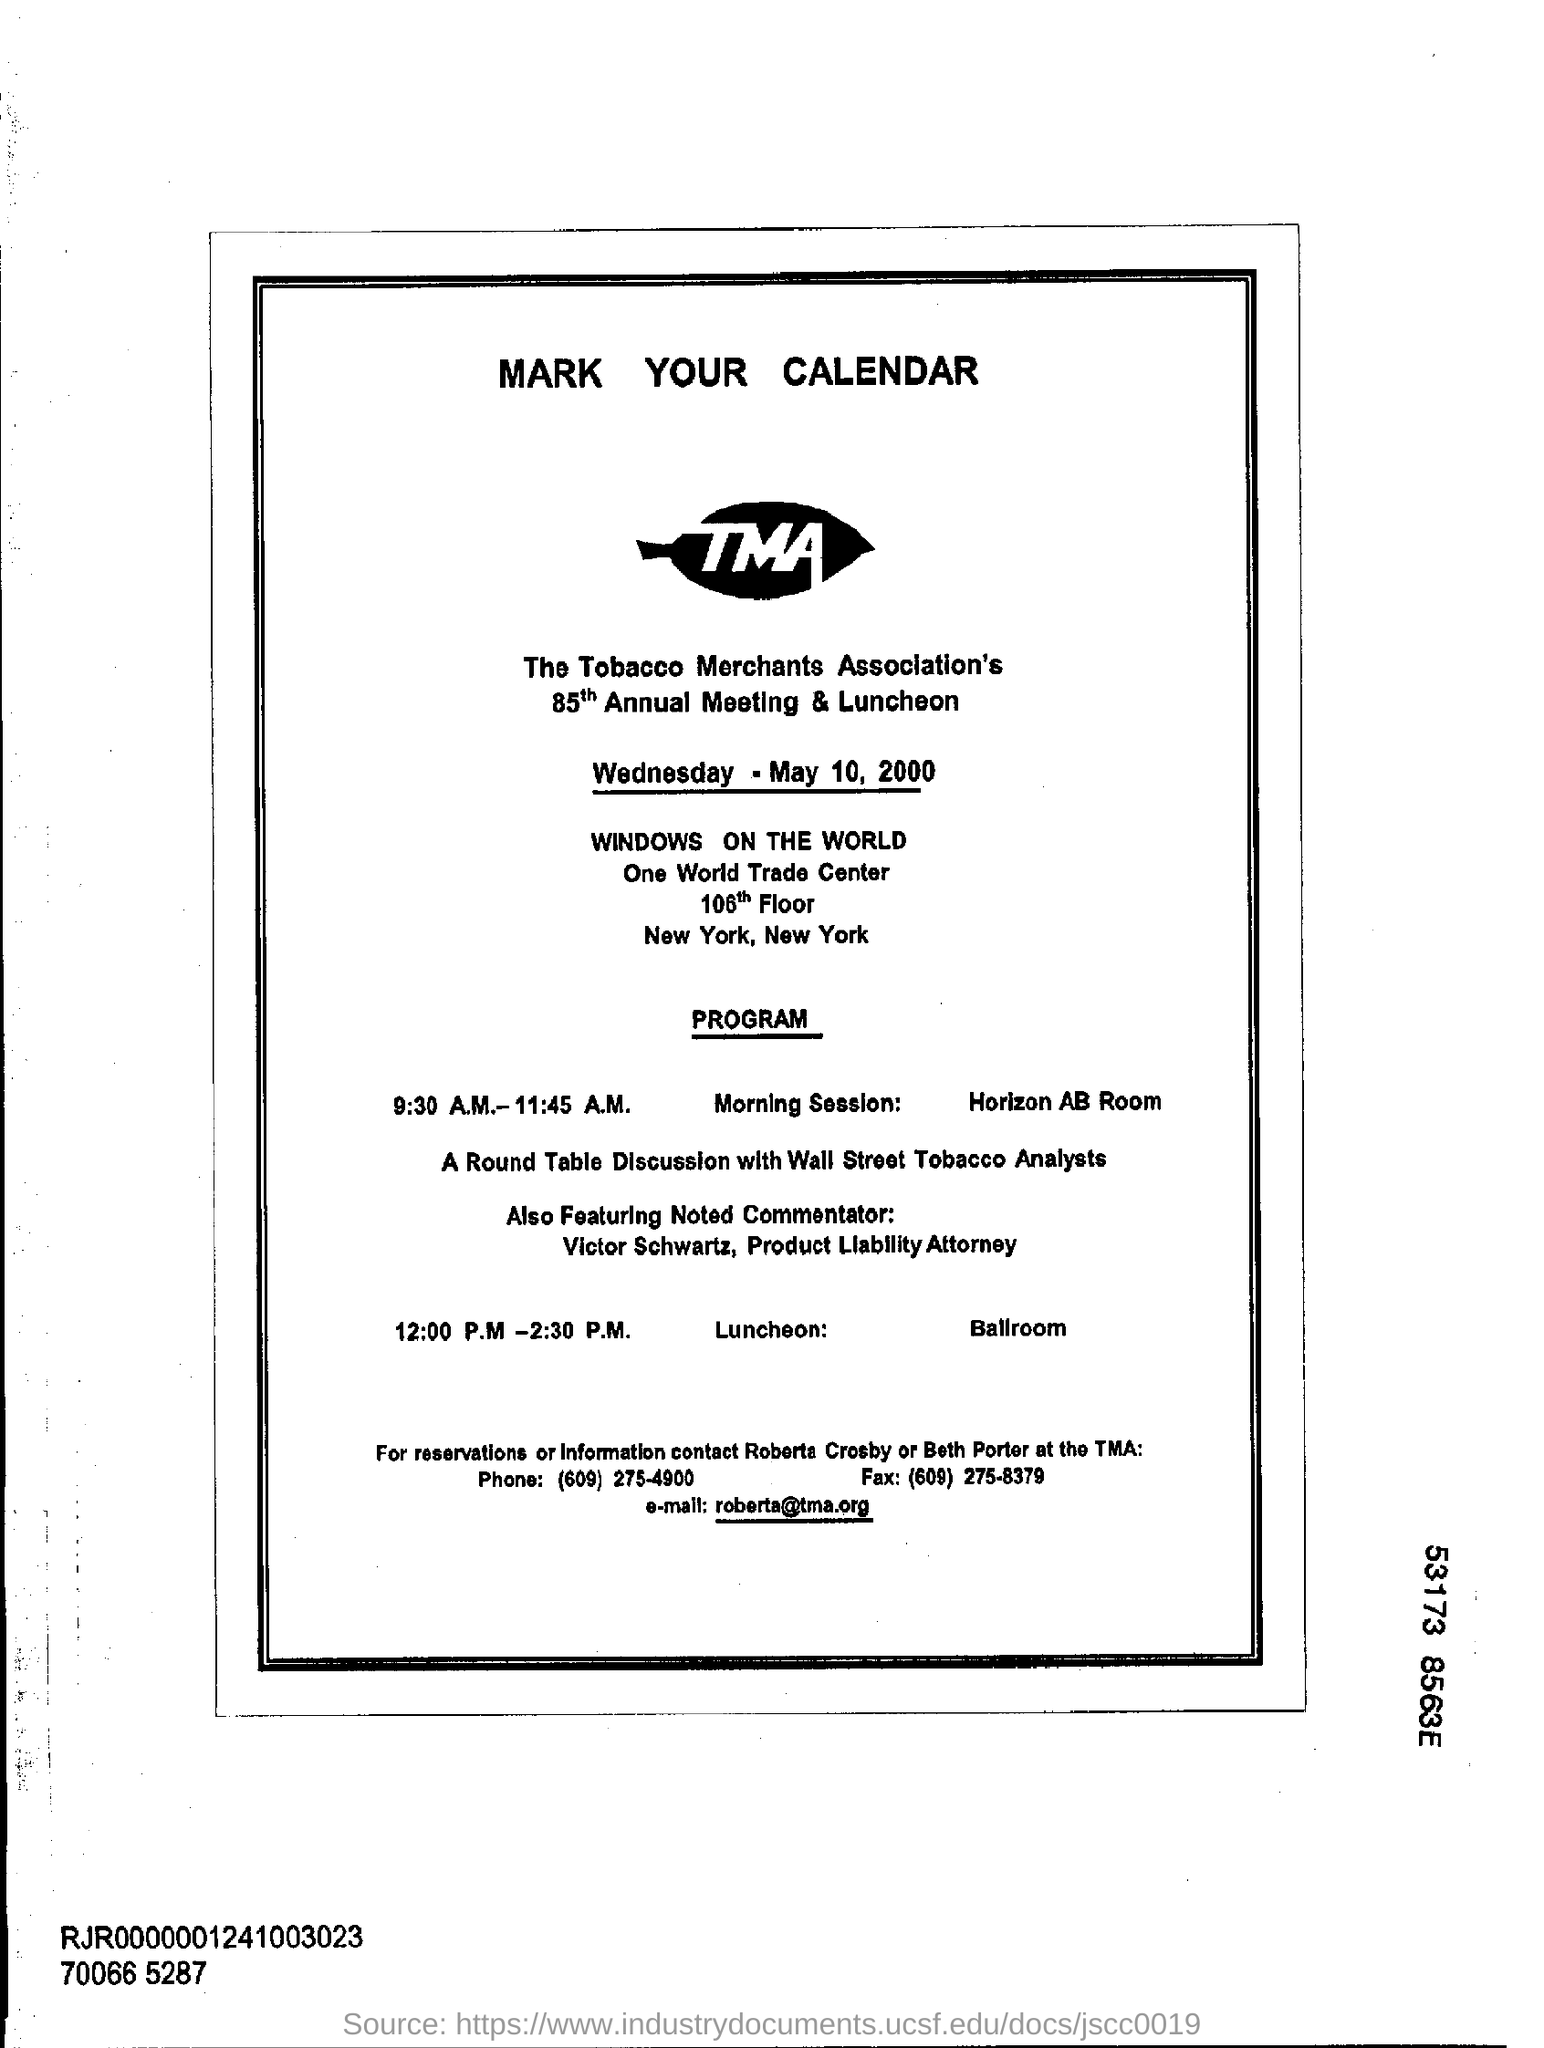Where is the morning session going to be held?
Your answer should be very brief. Horizon ab room. When is the Annual Meeting & Luncheon going to be held?
Give a very brief answer. Wednesday - may 10 , 2000. Which Noted Commentator is going to be featured?
Your answer should be very brief. Victor Schwartz. What is the contact email?
Your response must be concise. Roberta@tma.org. With whom is the Round Table Conference?
Your answer should be compact. Wall Street Tobacco Analysts. 